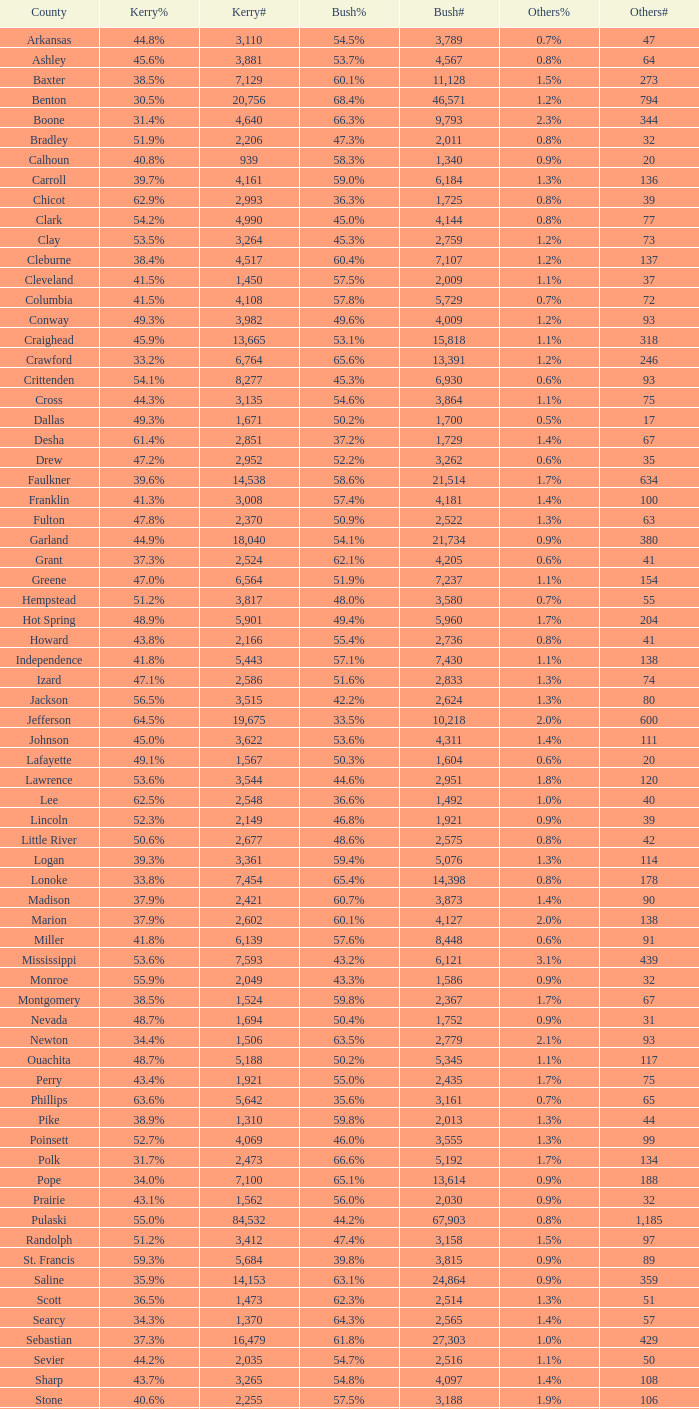For a bush% of "65.4%", what is the least possible bush#? 14398.0. 